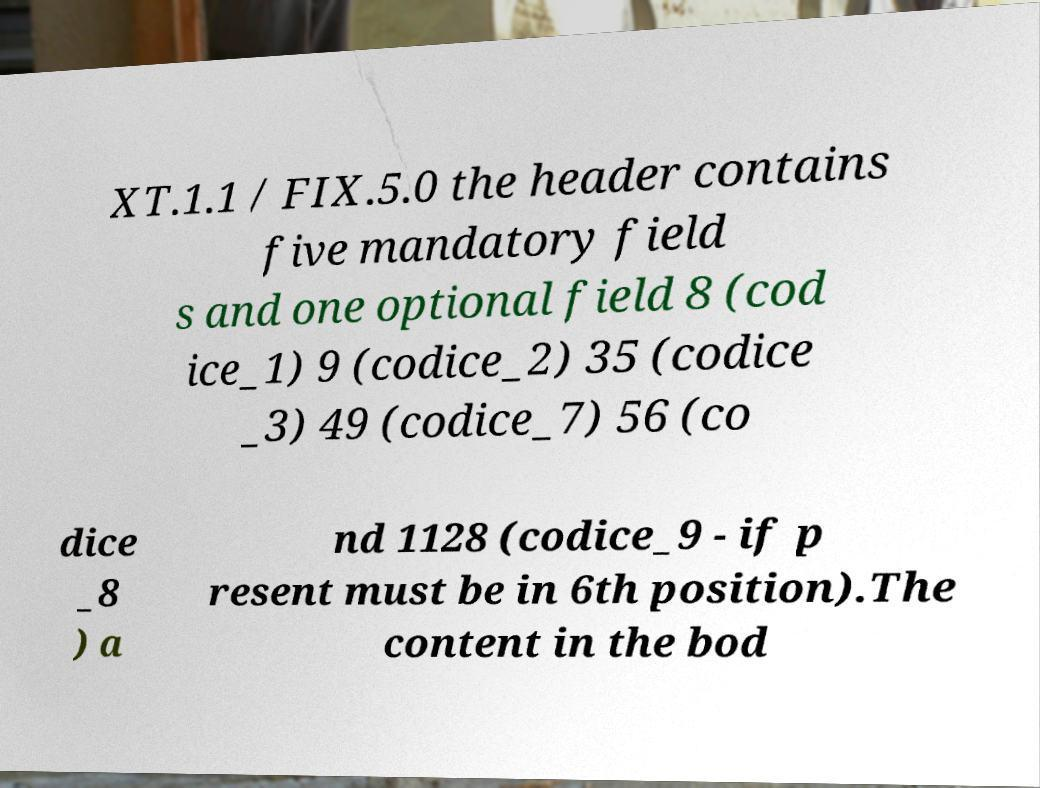Please read and relay the text visible in this image. What does it say? XT.1.1 / FIX.5.0 the header contains five mandatory field s and one optional field 8 (cod ice_1) 9 (codice_2) 35 (codice _3) 49 (codice_7) 56 (co dice _8 ) a nd 1128 (codice_9 - if p resent must be in 6th position).The content in the bod 